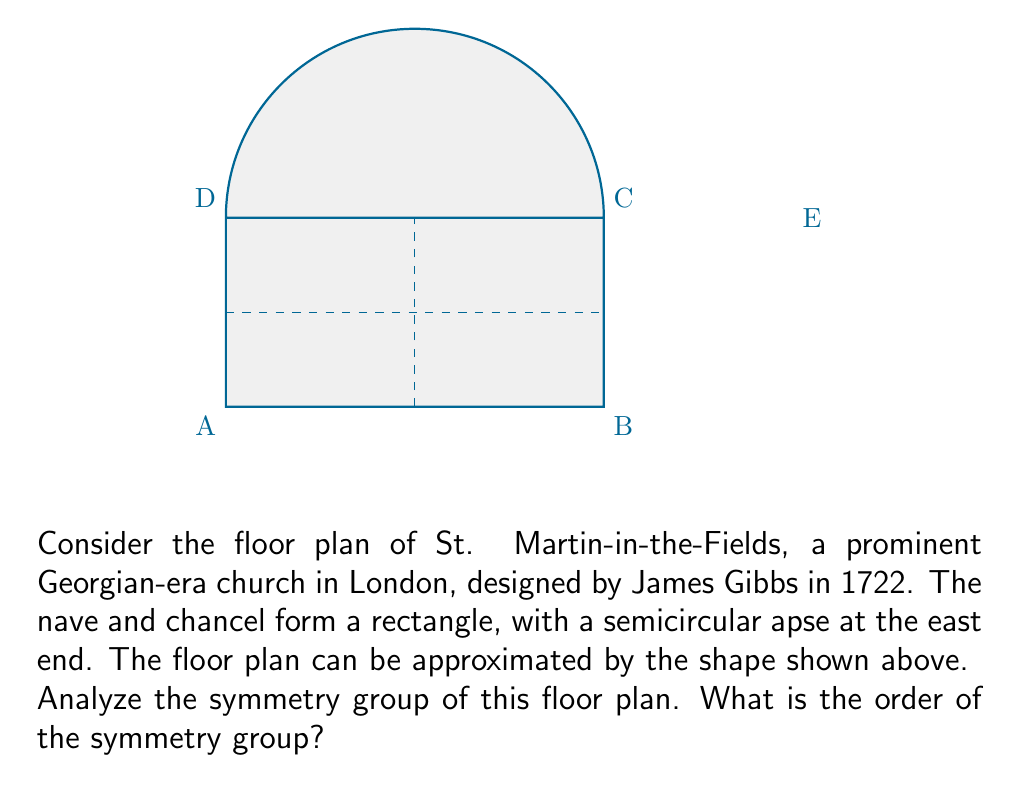Give your solution to this math problem. To determine the order of the symmetry group, we need to identify all the symmetries of the floor plan:

1. Rotational symmetries:
   - Identity (rotation by 0°)
   - Rotation by 180° around the center of the rectangle

2. Reflection symmetries:
   - Reflection across the vertical line through the center (line CE)
   - Reflection across the horizontal line through the center (line AB)

Let's verify these symmetries:

- The 180° rotation maps A to C, B to D, and E to itself.
- The vertical reflection maps A to B, C to D, and E to itself.
- The horizontal reflection maps A to D, B to C, and E to itself.

These transformations form a group because:
- They are closed under composition
- The identity element exists
- Each element has an inverse
- The composition is associative

To determine the order of the group, we count the number of distinct symmetries:
1. Identity
2. 180° rotation
3. Vertical reflection
4. Horizontal reflection

Therefore, the symmetry group has 4 elements.

This group is isomorphic to the Klein four-group, also known as $V_4$ or $C_2 \times C_2$.
Answer: 4 